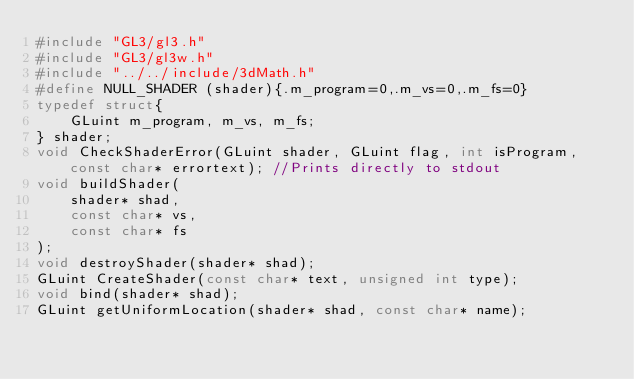Convert code to text. <code><loc_0><loc_0><loc_500><loc_500><_C_>#include "GL3/gl3.h"
#include "GL3/gl3w.h"
#include "../../include/3dMath.h"
#define NULL_SHADER (shader){.m_program=0,.m_vs=0,.m_fs=0}
typedef struct{
	GLuint m_program, m_vs, m_fs;
} shader;
void CheckShaderError(GLuint shader, GLuint flag, int isProgram, const char* errortext); //Prints directly to stdout
void buildShader(
	shader* shad,
	const char* vs,
	const char* fs
);
void destroyShader(shader* shad);
GLuint CreateShader(const char* text, unsigned int type);
void bind(shader* shad);
GLuint getUniformLocation(shader* shad, const char* name);</code> 